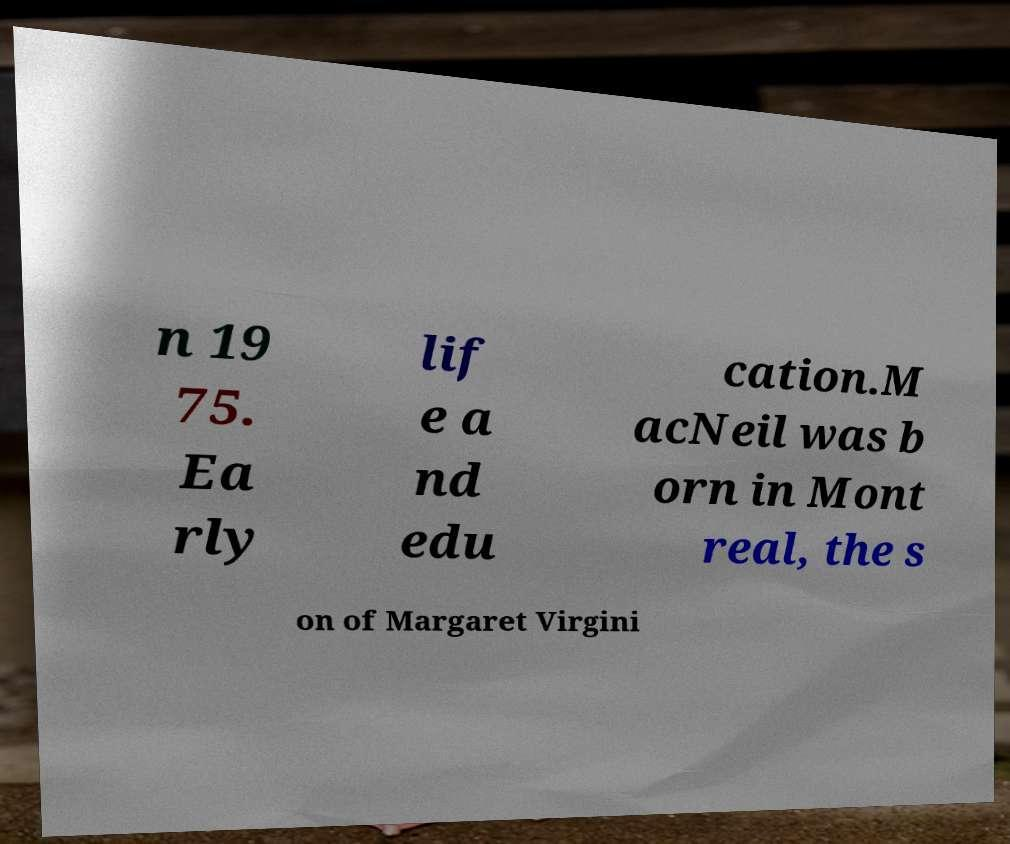What messages or text are displayed in this image? I need them in a readable, typed format. n 19 75. Ea rly lif e a nd edu cation.M acNeil was b orn in Mont real, the s on of Margaret Virgini 